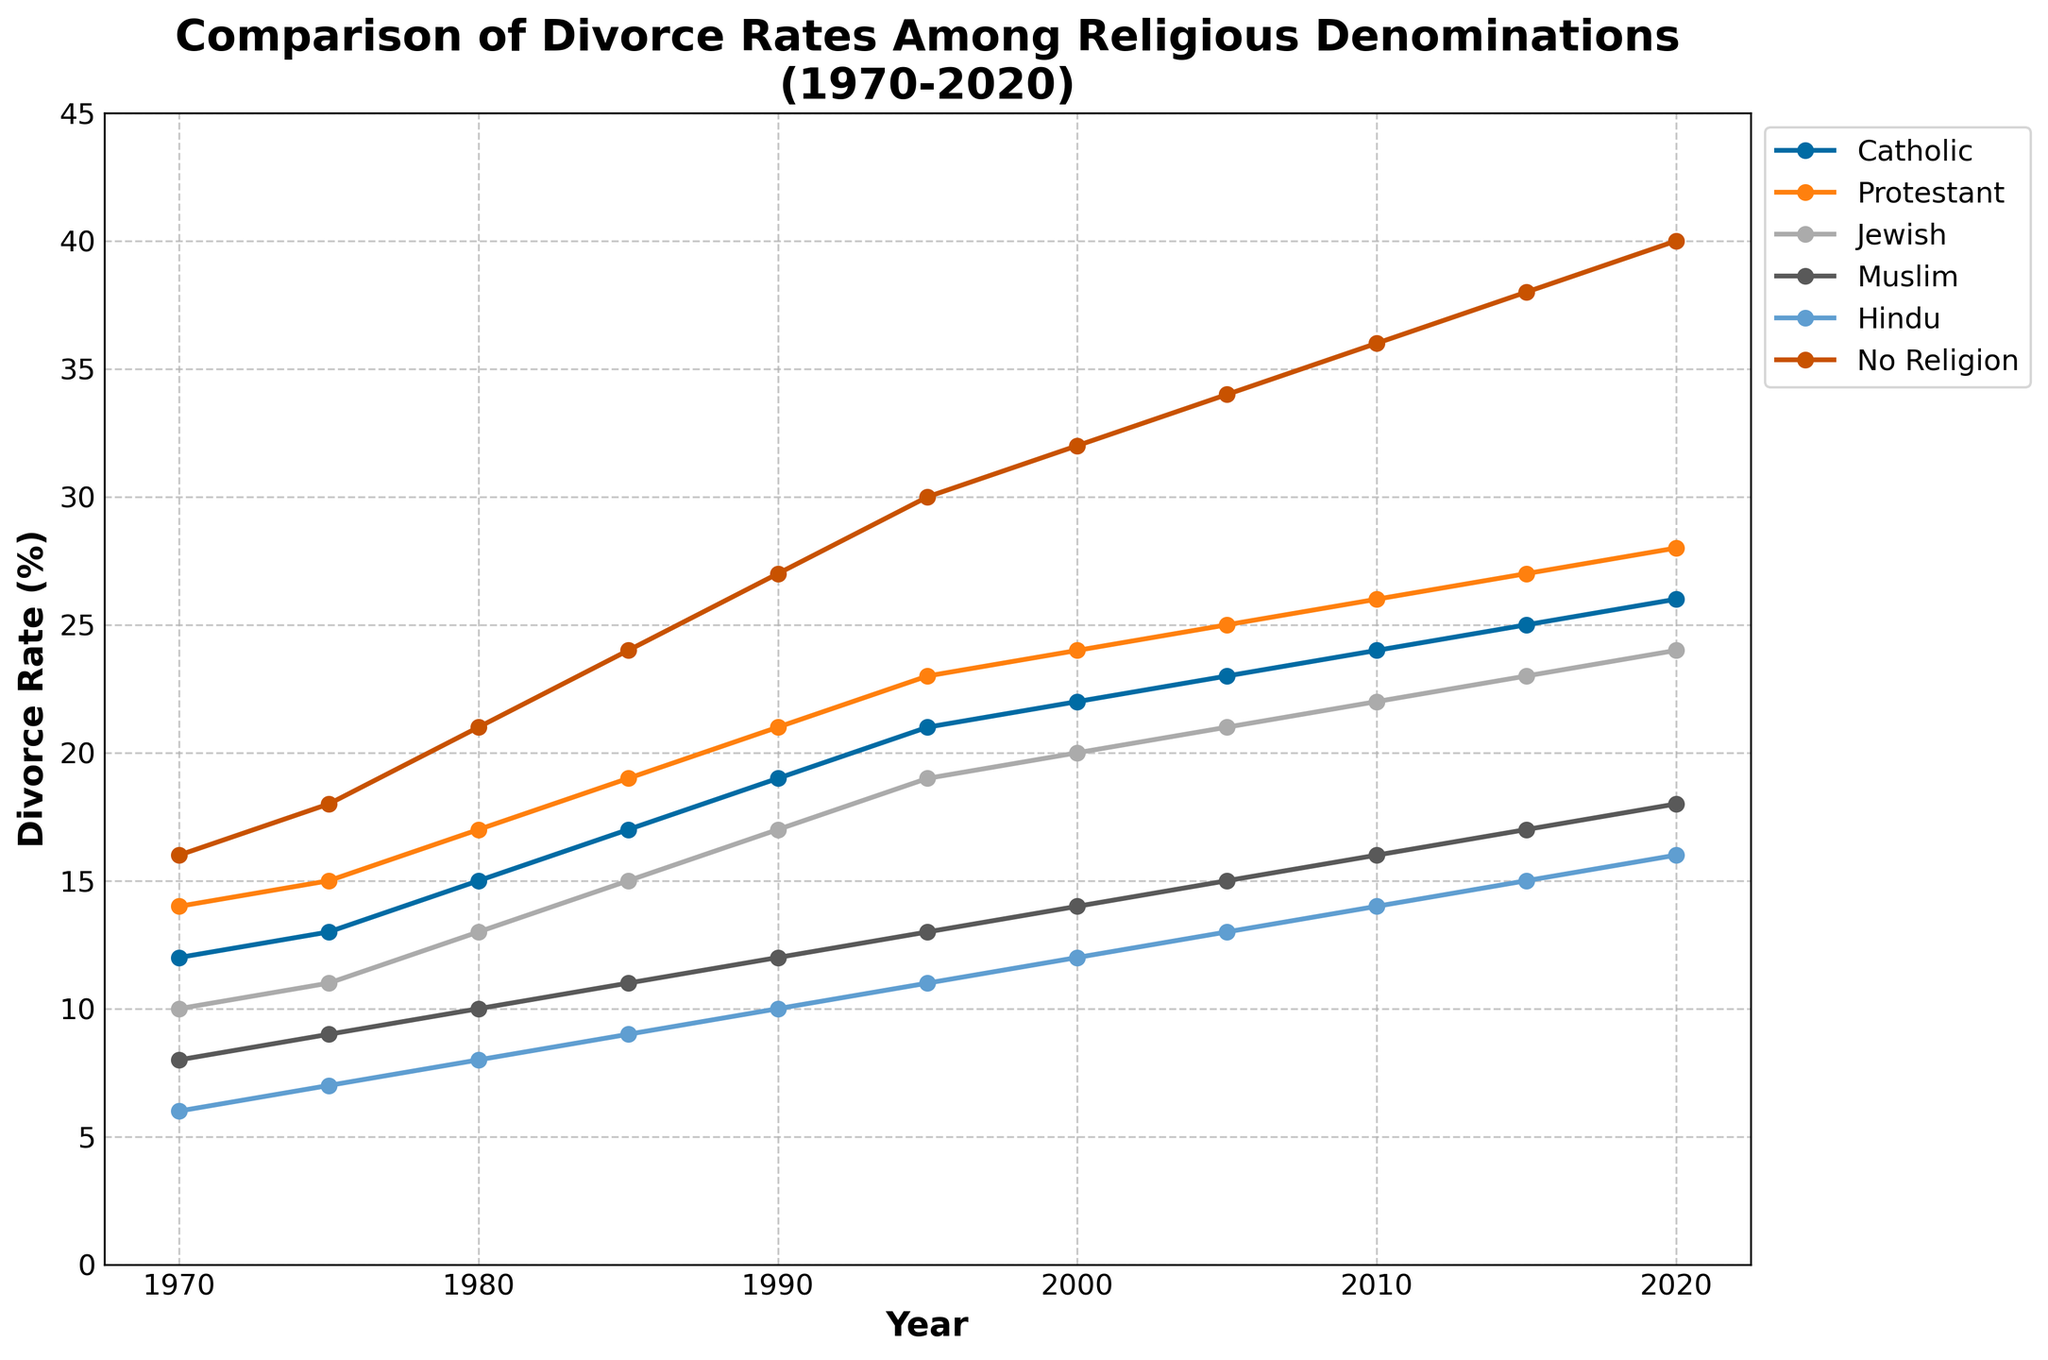Which denomination had the highest divorce rate in 2020? In 2020, the 'No Religion' group had the highest divorce rate, as it stands at 40%, which is visible from the figure showing the trend lines for each denomination.
Answer: No Religion How much did the divorce rate for Protestants increase from 1970 to 2020? The divorce rate for Protestants in 1970 was 14%, and it increased to 28% in 2020. The difference is 28% - 14% = 14%.
Answer: 14% Which denomination showed the least increase in divorce rates from 1970 to 2020? By comparing the increase for each denomination, Muslims had the smallest growth. In 1970, the rate was 8%, and in 2020, it was 18%, a total increase of 10 percentage points.
Answer: Muslim In which decade did Catholics experience the highest percentage increase in divorce rates? Calculate the percentage increase for each decade. Between 1985 (17%) and 1990 (19%): (19-17)/17 * 100 = 11.76%, the highest percentage increase for Catholics in any decade.
Answer: 1980-1990 What was the average divorce rate for Hindus over the entire time period? Adding the rates for each year: 6+7+8+9+10+11+12+13+14+15+16 = 121. Divide by the number of years (11): 121/11 ≈ 11%.
Answer: 11% Which denominations had a higher divorce rate than Muslims in 1995? In 1995, Muslims had a rate of 13%. Comparing this to other denominations: Catholics (21%), Protestants (23%), Jewish (19%), and No Religion (30%) had higher rates, while Hindus (11%) did not.
Answer: Catholic, Protestant, Jewish, No Religion By how much did the divorce rate of Jewish followers increase between 2000 and 2010? In 2000, the rate was 20%, and by 2010, it increased to 22%. The increase is 22% - 20% = 2%.
Answer: 2% Which denomination consistently had the lowest divorce rate every year? By visually inspecting each trend line for the lowest position throughout the years, Hindus consistently had the lowest divorce rate.
Answer: Hindu How did the trends for 'No Religion' and 'Catholics' compare between 1970-2020? Both groups show an upward trend, but 'No Religion' started higher and increased from 16% to 40% while Catholics increased from 12% to 26%, indicating 'No Religion' had a steeper rise.
Answer: No Religion had a steeper rise What is the sum of the divorce rates for all denominations in the year 1980? Summing the divorce rates for the year 1980 for each denomination: 15 + 17 + 13 + 10 + 8 + 21 = 84%.
Answer: 84% 